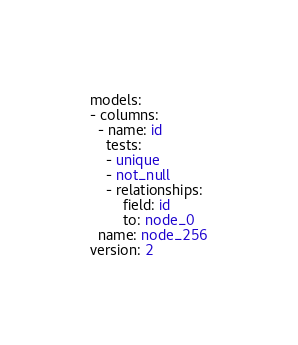Convert code to text. <code><loc_0><loc_0><loc_500><loc_500><_YAML_>models:
- columns:
  - name: id
    tests:
    - unique
    - not_null
    - relationships:
        field: id
        to: node_0
  name: node_256
version: 2
</code> 